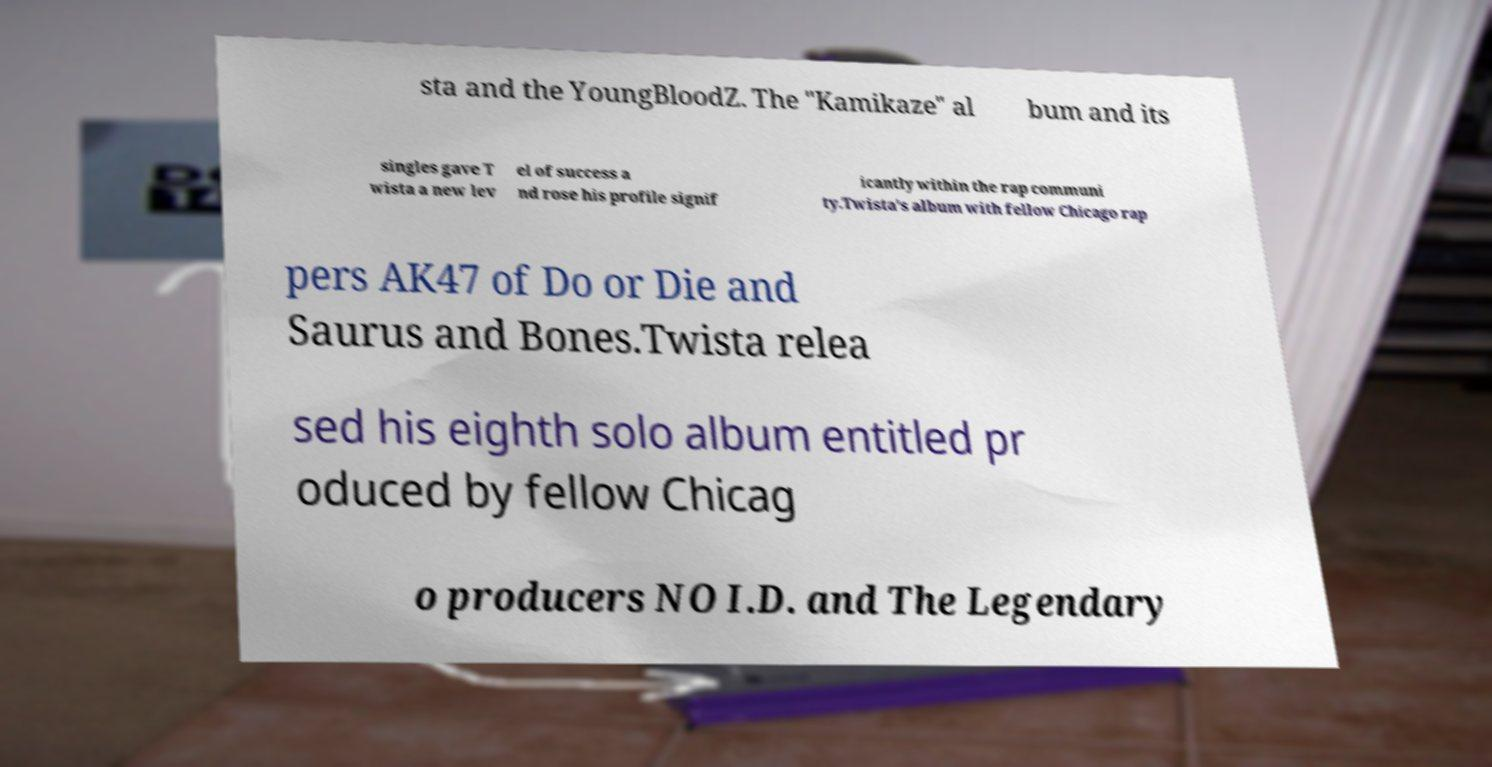What messages or text are displayed in this image? I need them in a readable, typed format. sta and the YoungBloodZ. The "Kamikaze" al bum and its singles gave T wista a new lev el of success a nd rose his profile signif icantly within the rap communi ty.Twista's album with fellow Chicago rap pers AK47 of Do or Die and Saurus and Bones.Twista relea sed his eighth solo album entitled pr oduced by fellow Chicag o producers NO I.D. and The Legendary 